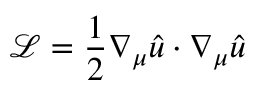Convert formula to latex. <formula><loc_0><loc_0><loc_500><loc_500>{ \mathcal { L } } = { \frac { 1 } { 2 } } \nabla _ { \mu } { \hat { u } } \cdot \nabla _ { \mu } { \hat { u } }</formula> 